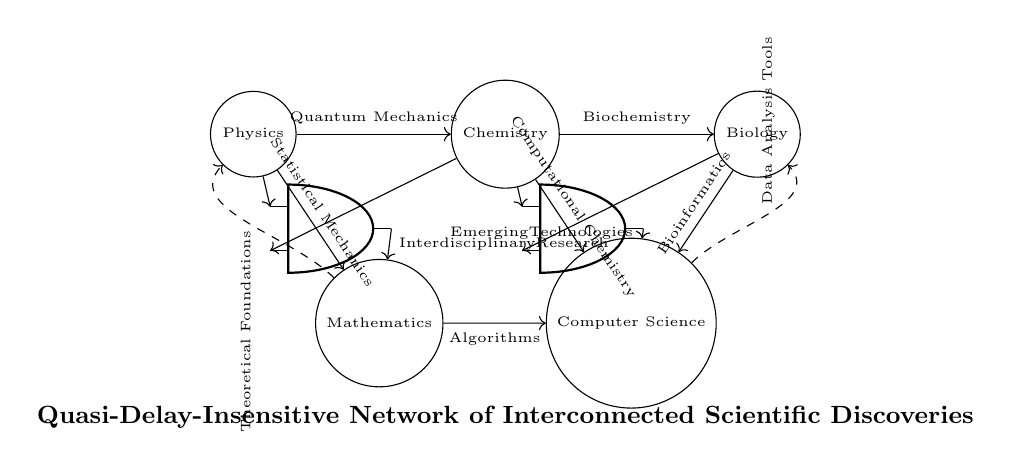What fields are represented in the nodes? The nodes represent Physics, Chemistry, Biology, Mathematics, and Computer Science. These are the scientific disciplines labeled on each node in the diagram.
Answer: Physics, Chemistry, Biology, Mathematics, Computer Science What is the first connection from Physics? The first connection from Physics is to Chemistry via Quantum Mechanics. This is indicated by the arrow pointing from the Physics node to the Chemistry node labeled with the term Quantum Mechanics.
Answer: Quantum Mechanics What type of C-element is used in the circuit? The circuit uses American AND ports as C-elements, as shown by the symbols at the intersections of the interdisciplinary connections. The ports are prominently placed within the circuit to signify contribution from various fields.
Answer: American AND ports Which interdisciplinary output is labeled with Emerging Technologies? Emerging Technologies is labeled as the output from the second C-element, which combines inputs from Chemistry and Biology to reflect the convergence of these disciplines. The connection flowing to Computer Science from this C-element is marked with that label.
Answer: Emerging Technologies How many dashed feedback loops are present? There are two dashed feedback loops present in the circuit, one from Mathematics to Physics and another from Computer Science to Biology. Each loop connects the disciplines to indicate ongoing influence.
Answer: Two Which scientific discovery leads to Computational Chemistry in the diagram? Chemistry leads to Computational Chemistry, as indicated by the arrow connecting these two nodes in the diagram. This shows the flow of influence between these fields based on their scientific relationships.
Answer: Chemistry 